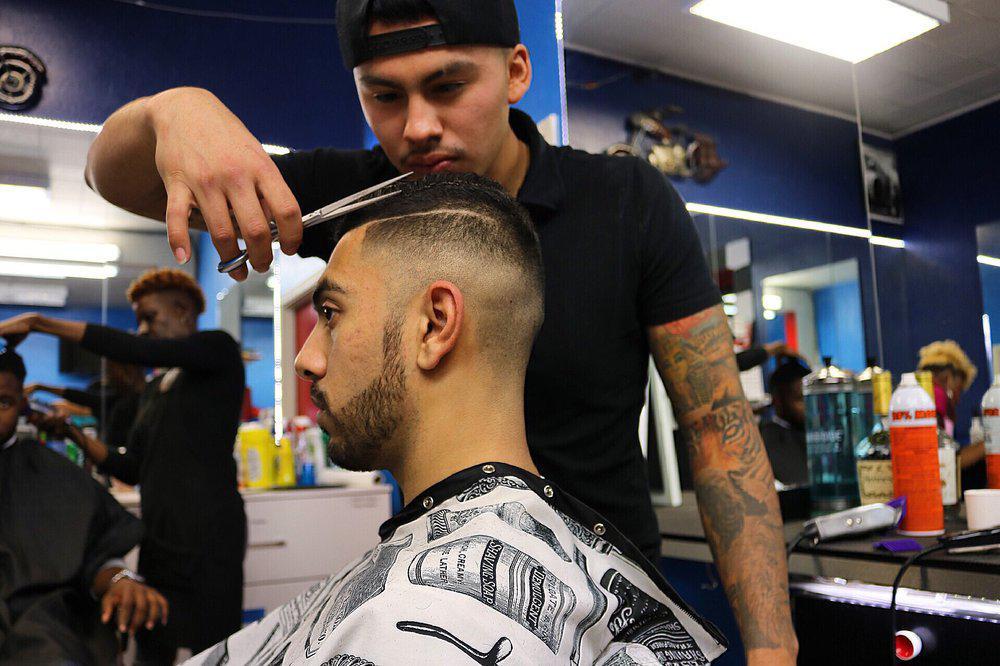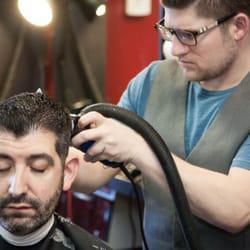The first image is the image on the left, the second image is the image on the right. For the images displayed, is the sentence "An image shows a male barber with eyeglasses behind a customer, working on hair." factually correct? Answer yes or no. Yes. The first image is the image on the left, the second image is the image on the right. Assess this claim about the two images: "The male barber in the image on the right is wearing glasses.". Correct or not? Answer yes or no. Yes. 